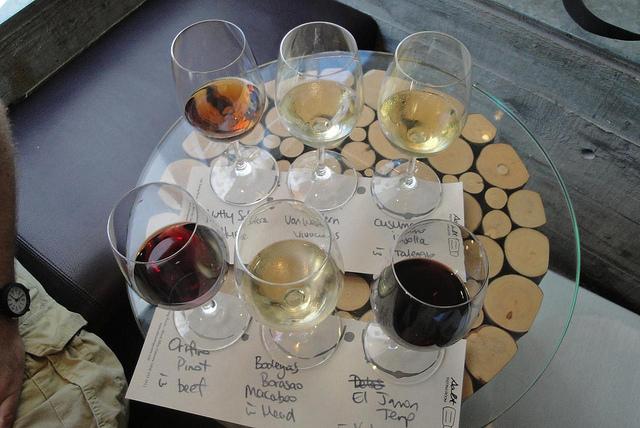Is this a fancy restaurant?
Quick response, please. Yes. Is there any food on the table?
Keep it brief. No. How many glasses are on the table?
Concise answer only. 6. How many glasses are there?
Give a very brief answer. 6. What is written on the tablecloth next to each glass?
Be succinct. Wine names. What kind of tasting is this?
Answer briefly. Wine. What is she drinking?
Answer briefly. Wine. Is this a restaurant?
Give a very brief answer. Yes. Is there a glass filled with candy in the photo?
Be succinct. No. 